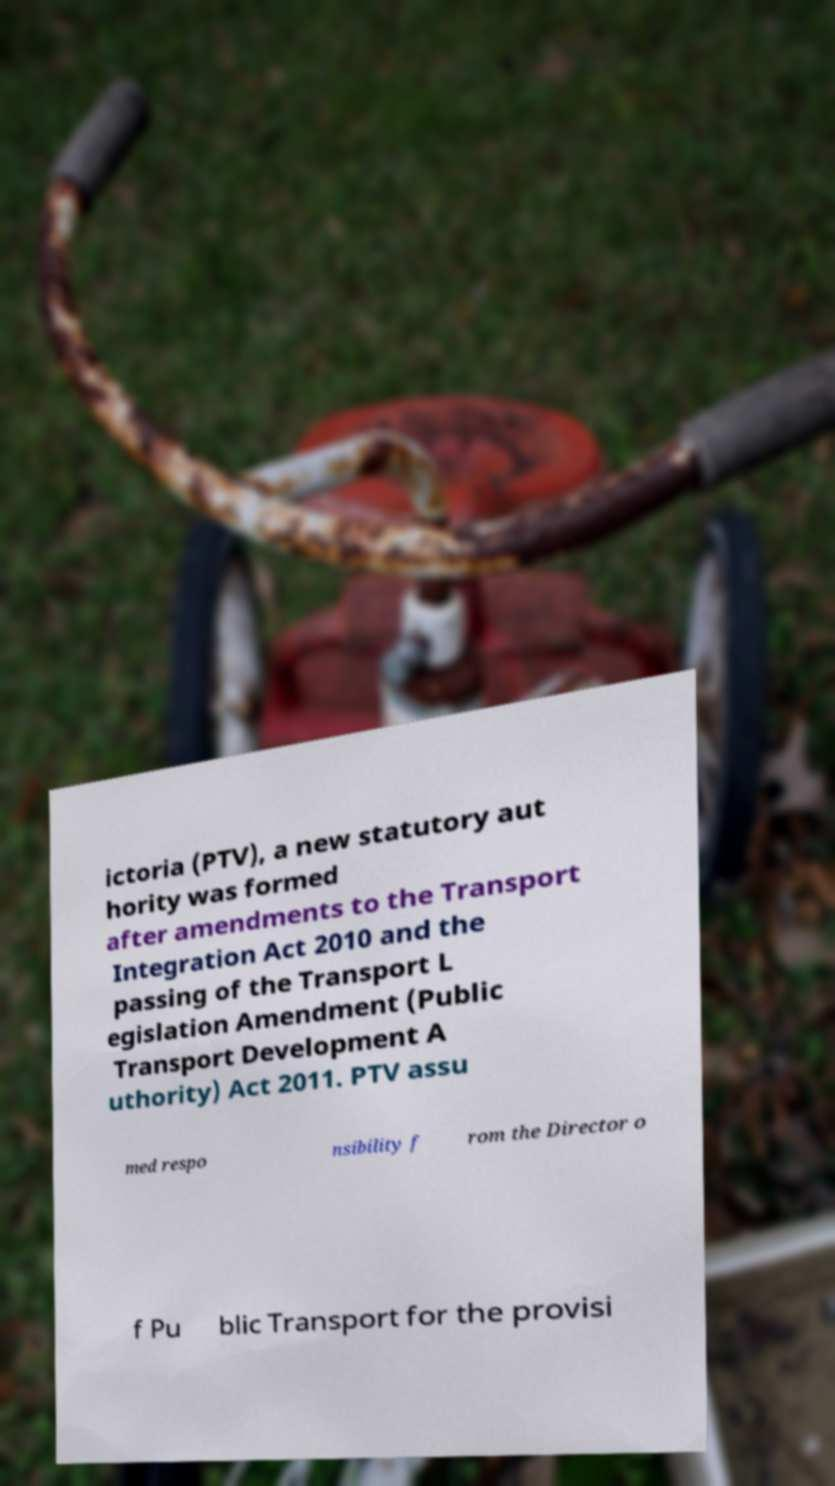I need the written content from this picture converted into text. Can you do that? ictoria (PTV), a new statutory aut hority was formed after amendments to the Transport Integration Act 2010 and the passing of the Transport L egislation Amendment (Public Transport Development A uthority) Act 2011. PTV assu med respo nsibility f rom the Director o f Pu blic Transport for the provisi 